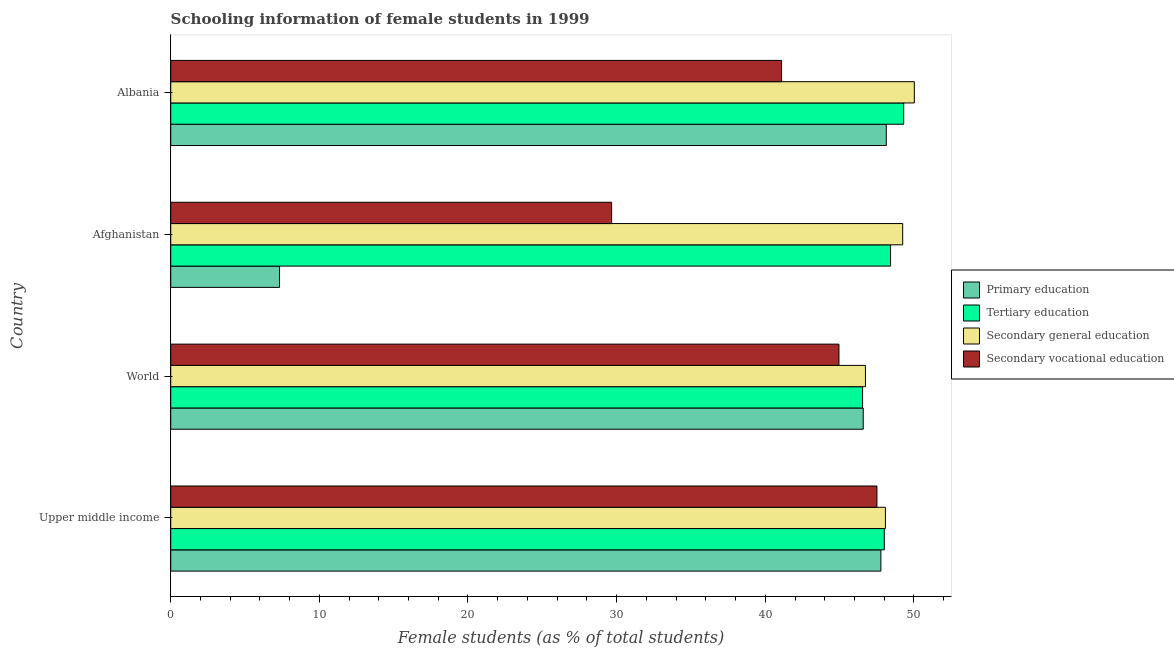How many different coloured bars are there?
Provide a short and direct response. 4. How many groups of bars are there?
Offer a very short reply. 4. How many bars are there on the 3rd tick from the top?
Ensure brevity in your answer.  4. How many bars are there on the 1st tick from the bottom?
Give a very brief answer. 4. What is the label of the 4th group of bars from the top?
Give a very brief answer. Upper middle income. What is the percentage of female students in primary education in Upper middle income?
Keep it short and to the point. 47.78. Across all countries, what is the maximum percentage of female students in secondary vocational education?
Make the answer very short. 47.51. Across all countries, what is the minimum percentage of female students in secondary vocational education?
Your answer should be very brief. 29.66. In which country was the percentage of female students in primary education maximum?
Provide a short and direct response. Albania. In which country was the percentage of female students in secondary vocational education minimum?
Offer a terse response. Afghanistan. What is the total percentage of female students in tertiary education in the graph?
Your answer should be compact. 192.3. What is the difference between the percentage of female students in tertiary education in Afghanistan and that in World?
Give a very brief answer. 1.88. What is the difference between the percentage of female students in primary education in World and the percentage of female students in secondary education in Upper middle income?
Your answer should be very brief. -1.49. What is the average percentage of female students in secondary vocational education per country?
Ensure brevity in your answer.  40.81. What is the difference between the percentage of female students in tertiary education and percentage of female students in secondary vocational education in World?
Keep it short and to the point. 1.59. In how many countries, is the percentage of female students in tertiary education greater than 44 %?
Keep it short and to the point. 4. What is the ratio of the percentage of female students in secondary vocational education in Upper middle income to that in World?
Make the answer very short. 1.06. Is the percentage of female students in tertiary education in Albania less than that in World?
Offer a very short reply. No. Is the difference between the percentage of female students in primary education in Afghanistan and Upper middle income greater than the difference between the percentage of female students in secondary education in Afghanistan and Upper middle income?
Keep it short and to the point. No. What is the difference between the highest and the second highest percentage of female students in primary education?
Provide a short and direct response. 0.36. What is the difference between the highest and the lowest percentage of female students in secondary vocational education?
Keep it short and to the point. 17.85. Is the sum of the percentage of female students in tertiary education in Albania and Upper middle income greater than the maximum percentage of female students in secondary education across all countries?
Your response must be concise. Yes. Is it the case that in every country, the sum of the percentage of female students in primary education and percentage of female students in tertiary education is greater than the sum of percentage of female students in secondary education and percentage of female students in secondary vocational education?
Your response must be concise. No. What does the 3rd bar from the top in World represents?
Provide a short and direct response. Tertiary education. What does the 2nd bar from the bottom in Upper middle income represents?
Ensure brevity in your answer.  Tertiary education. Are the values on the major ticks of X-axis written in scientific E-notation?
Offer a very short reply. No. Does the graph contain any zero values?
Make the answer very short. No. Where does the legend appear in the graph?
Offer a very short reply. Center right. How are the legend labels stacked?
Your answer should be compact. Vertical. What is the title of the graph?
Offer a terse response. Schooling information of female students in 1999. What is the label or title of the X-axis?
Provide a short and direct response. Female students (as % of total students). What is the Female students (as % of total students) of Primary education in Upper middle income?
Give a very brief answer. 47.78. What is the Female students (as % of total students) in Tertiary education in Upper middle income?
Give a very brief answer. 48.01. What is the Female students (as % of total students) in Secondary general education in Upper middle income?
Keep it short and to the point. 48.08. What is the Female students (as % of total students) of Secondary vocational education in Upper middle income?
Your answer should be very brief. 47.51. What is the Female students (as % of total students) of Primary education in World?
Your answer should be very brief. 46.59. What is the Female students (as % of total students) of Tertiary education in World?
Give a very brief answer. 46.55. What is the Female students (as % of total students) of Secondary general education in World?
Ensure brevity in your answer.  46.74. What is the Female students (as % of total students) of Secondary vocational education in World?
Your answer should be very brief. 44.96. What is the Female students (as % of total students) of Primary education in Afghanistan?
Your answer should be compact. 7.32. What is the Female students (as % of total students) of Tertiary education in Afghanistan?
Your answer should be compact. 48.43. What is the Female students (as % of total students) of Secondary general education in Afghanistan?
Keep it short and to the point. 49.25. What is the Female students (as % of total students) of Secondary vocational education in Afghanistan?
Give a very brief answer. 29.66. What is the Female students (as % of total students) in Primary education in Albania?
Ensure brevity in your answer.  48.14. What is the Female students (as % of total students) in Tertiary education in Albania?
Your answer should be compact. 49.31. What is the Female students (as % of total students) of Secondary general education in Albania?
Your answer should be compact. 50.03. What is the Female students (as % of total students) of Secondary vocational education in Albania?
Provide a succinct answer. 41.1. Across all countries, what is the maximum Female students (as % of total students) of Primary education?
Make the answer very short. 48.14. Across all countries, what is the maximum Female students (as % of total students) in Tertiary education?
Your answer should be very brief. 49.31. Across all countries, what is the maximum Female students (as % of total students) of Secondary general education?
Offer a terse response. 50.03. Across all countries, what is the maximum Female students (as % of total students) in Secondary vocational education?
Your answer should be compact. 47.51. Across all countries, what is the minimum Female students (as % of total students) in Primary education?
Provide a succinct answer. 7.32. Across all countries, what is the minimum Female students (as % of total students) in Tertiary education?
Offer a very short reply. 46.55. Across all countries, what is the minimum Female students (as % of total students) in Secondary general education?
Your answer should be compact. 46.74. Across all countries, what is the minimum Female students (as % of total students) in Secondary vocational education?
Provide a succinct answer. 29.66. What is the total Female students (as % of total students) of Primary education in the graph?
Your answer should be compact. 149.83. What is the total Female students (as % of total students) in Tertiary education in the graph?
Your answer should be very brief. 192.3. What is the total Female students (as % of total students) of Secondary general education in the graph?
Your answer should be compact. 194.1. What is the total Female students (as % of total students) in Secondary vocational education in the graph?
Offer a terse response. 163.23. What is the difference between the Female students (as % of total students) of Primary education in Upper middle income and that in World?
Give a very brief answer. 1.19. What is the difference between the Female students (as % of total students) of Tertiary education in Upper middle income and that in World?
Your response must be concise. 1.46. What is the difference between the Female students (as % of total students) in Secondary general education in Upper middle income and that in World?
Keep it short and to the point. 1.34. What is the difference between the Female students (as % of total students) in Secondary vocational education in Upper middle income and that in World?
Offer a very short reply. 2.55. What is the difference between the Female students (as % of total students) of Primary education in Upper middle income and that in Afghanistan?
Your response must be concise. 40.46. What is the difference between the Female students (as % of total students) in Tertiary education in Upper middle income and that in Afghanistan?
Give a very brief answer. -0.42. What is the difference between the Female students (as % of total students) of Secondary general education in Upper middle income and that in Afghanistan?
Provide a succinct answer. -1.16. What is the difference between the Female students (as % of total students) in Secondary vocational education in Upper middle income and that in Afghanistan?
Your answer should be very brief. 17.85. What is the difference between the Female students (as % of total students) of Primary education in Upper middle income and that in Albania?
Give a very brief answer. -0.36. What is the difference between the Female students (as % of total students) in Tertiary education in Upper middle income and that in Albania?
Keep it short and to the point. -1.3. What is the difference between the Female students (as % of total students) in Secondary general education in Upper middle income and that in Albania?
Provide a short and direct response. -1.94. What is the difference between the Female students (as % of total students) in Secondary vocational education in Upper middle income and that in Albania?
Provide a short and direct response. 6.42. What is the difference between the Female students (as % of total students) of Primary education in World and that in Afghanistan?
Your answer should be compact. 39.27. What is the difference between the Female students (as % of total students) of Tertiary education in World and that in Afghanistan?
Offer a very short reply. -1.88. What is the difference between the Female students (as % of total students) in Secondary general education in World and that in Afghanistan?
Ensure brevity in your answer.  -2.51. What is the difference between the Female students (as % of total students) of Secondary vocational education in World and that in Afghanistan?
Offer a terse response. 15.29. What is the difference between the Female students (as % of total students) of Primary education in World and that in Albania?
Provide a succinct answer. -1.55. What is the difference between the Female students (as % of total students) of Tertiary education in World and that in Albania?
Offer a very short reply. -2.77. What is the difference between the Female students (as % of total students) of Secondary general education in World and that in Albania?
Make the answer very short. -3.29. What is the difference between the Female students (as % of total students) of Secondary vocational education in World and that in Albania?
Ensure brevity in your answer.  3.86. What is the difference between the Female students (as % of total students) of Primary education in Afghanistan and that in Albania?
Make the answer very short. -40.82. What is the difference between the Female students (as % of total students) of Tertiary education in Afghanistan and that in Albania?
Your response must be concise. -0.88. What is the difference between the Female students (as % of total students) of Secondary general education in Afghanistan and that in Albania?
Give a very brief answer. -0.78. What is the difference between the Female students (as % of total students) of Secondary vocational education in Afghanistan and that in Albania?
Make the answer very short. -11.43. What is the difference between the Female students (as % of total students) in Primary education in Upper middle income and the Female students (as % of total students) in Tertiary education in World?
Keep it short and to the point. 1.23. What is the difference between the Female students (as % of total students) in Primary education in Upper middle income and the Female students (as % of total students) in Secondary general education in World?
Your answer should be very brief. 1.04. What is the difference between the Female students (as % of total students) of Primary education in Upper middle income and the Female students (as % of total students) of Secondary vocational education in World?
Your response must be concise. 2.82. What is the difference between the Female students (as % of total students) of Tertiary education in Upper middle income and the Female students (as % of total students) of Secondary general education in World?
Provide a succinct answer. 1.27. What is the difference between the Female students (as % of total students) in Tertiary education in Upper middle income and the Female students (as % of total students) in Secondary vocational education in World?
Your answer should be compact. 3.05. What is the difference between the Female students (as % of total students) of Secondary general education in Upper middle income and the Female students (as % of total students) of Secondary vocational education in World?
Ensure brevity in your answer.  3.13. What is the difference between the Female students (as % of total students) in Primary education in Upper middle income and the Female students (as % of total students) in Tertiary education in Afghanistan?
Make the answer very short. -0.65. What is the difference between the Female students (as % of total students) of Primary education in Upper middle income and the Female students (as % of total students) of Secondary general education in Afghanistan?
Make the answer very short. -1.47. What is the difference between the Female students (as % of total students) of Primary education in Upper middle income and the Female students (as % of total students) of Secondary vocational education in Afghanistan?
Keep it short and to the point. 18.11. What is the difference between the Female students (as % of total students) of Tertiary education in Upper middle income and the Female students (as % of total students) of Secondary general education in Afghanistan?
Give a very brief answer. -1.24. What is the difference between the Female students (as % of total students) in Tertiary education in Upper middle income and the Female students (as % of total students) in Secondary vocational education in Afghanistan?
Give a very brief answer. 18.35. What is the difference between the Female students (as % of total students) of Secondary general education in Upper middle income and the Female students (as % of total students) of Secondary vocational education in Afghanistan?
Provide a short and direct response. 18.42. What is the difference between the Female students (as % of total students) in Primary education in Upper middle income and the Female students (as % of total students) in Tertiary education in Albania?
Your answer should be compact. -1.54. What is the difference between the Female students (as % of total students) in Primary education in Upper middle income and the Female students (as % of total students) in Secondary general education in Albania?
Your answer should be very brief. -2.25. What is the difference between the Female students (as % of total students) in Primary education in Upper middle income and the Female students (as % of total students) in Secondary vocational education in Albania?
Ensure brevity in your answer.  6.68. What is the difference between the Female students (as % of total students) of Tertiary education in Upper middle income and the Female students (as % of total students) of Secondary general education in Albania?
Offer a very short reply. -2.02. What is the difference between the Female students (as % of total students) of Tertiary education in Upper middle income and the Female students (as % of total students) of Secondary vocational education in Albania?
Your answer should be very brief. 6.91. What is the difference between the Female students (as % of total students) of Secondary general education in Upper middle income and the Female students (as % of total students) of Secondary vocational education in Albania?
Offer a very short reply. 6.99. What is the difference between the Female students (as % of total students) in Primary education in World and the Female students (as % of total students) in Tertiary education in Afghanistan?
Your answer should be very brief. -1.84. What is the difference between the Female students (as % of total students) of Primary education in World and the Female students (as % of total students) of Secondary general education in Afghanistan?
Keep it short and to the point. -2.65. What is the difference between the Female students (as % of total students) of Primary education in World and the Female students (as % of total students) of Secondary vocational education in Afghanistan?
Offer a terse response. 16.93. What is the difference between the Female students (as % of total students) of Tertiary education in World and the Female students (as % of total students) of Secondary general education in Afghanistan?
Ensure brevity in your answer.  -2.7. What is the difference between the Female students (as % of total students) in Tertiary education in World and the Female students (as % of total students) in Secondary vocational education in Afghanistan?
Your answer should be very brief. 16.88. What is the difference between the Female students (as % of total students) of Secondary general education in World and the Female students (as % of total students) of Secondary vocational education in Afghanistan?
Your answer should be very brief. 17.08. What is the difference between the Female students (as % of total students) of Primary education in World and the Female students (as % of total students) of Tertiary education in Albania?
Your answer should be compact. -2.72. What is the difference between the Female students (as % of total students) in Primary education in World and the Female students (as % of total students) in Secondary general education in Albania?
Offer a very short reply. -3.44. What is the difference between the Female students (as % of total students) in Primary education in World and the Female students (as % of total students) in Secondary vocational education in Albania?
Your response must be concise. 5.5. What is the difference between the Female students (as % of total students) of Tertiary education in World and the Female students (as % of total students) of Secondary general education in Albania?
Your answer should be very brief. -3.48. What is the difference between the Female students (as % of total students) in Tertiary education in World and the Female students (as % of total students) in Secondary vocational education in Albania?
Make the answer very short. 5.45. What is the difference between the Female students (as % of total students) of Secondary general education in World and the Female students (as % of total students) of Secondary vocational education in Albania?
Your response must be concise. 5.64. What is the difference between the Female students (as % of total students) in Primary education in Afghanistan and the Female students (as % of total students) in Tertiary education in Albania?
Ensure brevity in your answer.  -41.99. What is the difference between the Female students (as % of total students) of Primary education in Afghanistan and the Female students (as % of total students) of Secondary general education in Albania?
Your answer should be very brief. -42.71. What is the difference between the Female students (as % of total students) in Primary education in Afghanistan and the Female students (as % of total students) in Secondary vocational education in Albania?
Keep it short and to the point. -33.77. What is the difference between the Female students (as % of total students) in Tertiary education in Afghanistan and the Female students (as % of total students) in Secondary general education in Albania?
Your answer should be compact. -1.6. What is the difference between the Female students (as % of total students) in Tertiary education in Afghanistan and the Female students (as % of total students) in Secondary vocational education in Albania?
Offer a terse response. 7.34. What is the difference between the Female students (as % of total students) of Secondary general education in Afghanistan and the Female students (as % of total students) of Secondary vocational education in Albania?
Your response must be concise. 8.15. What is the average Female students (as % of total students) of Primary education per country?
Offer a very short reply. 37.46. What is the average Female students (as % of total students) of Tertiary education per country?
Offer a terse response. 48.07. What is the average Female students (as % of total students) of Secondary general education per country?
Your response must be concise. 48.52. What is the average Female students (as % of total students) of Secondary vocational education per country?
Offer a very short reply. 40.81. What is the difference between the Female students (as % of total students) of Primary education and Female students (as % of total students) of Tertiary education in Upper middle income?
Make the answer very short. -0.23. What is the difference between the Female students (as % of total students) in Primary education and Female students (as % of total students) in Secondary general education in Upper middle income?
Ensure brevity in your answer.  -0.31. What is the difference between the Female students (as % of total students) in Primary education and Female students (as % of total students) in Secondary vocational education in Upper middle income?
Your answer should be compact. 0.27. What is the difference between the Female students (as % of total students) in Tertiary education and Female students (as % of total students) in Secondary general education in Upper middle income?
Offer a terse response. -0.07. What is the difference between the Female students (as % of total students) of Tertiary education and Female students (as % of total students) of Secondary vocational education in Upper middle income?
Offer a terse response. 0.5. What is the difference between the Female students (as % of total students) of Secondary general education and Female students (as % of total students) of Secondary vocational education in Upper middle income?
Provide a succinct answer. 0.57. What is the difference between the Female students (as % of total students) in Primary education and Female students (as % of total students) in Tertiary education in World?
Provide a short and direct response. 0.04. What is the difference between the Female students (as % of total students) of Primary education and Female students (as % of total students) of Secondary general education in World?
Provide a short and direct response. -0.15. What is the difference between the Female students (as % of total students) of Primary education and Female students (as % of total students) of Secondary vocational education in World?
Your answer should be very brief. 1.63. What is the difference between the Female students (as % of total students) in Tertiary education and Female students (as % of total students) in Secondary general education in World?
Your response must be concise. -0.19. What is the difference between the Female students (as % of total students) of Tertiary education and Female students (as % of total students) of Secondary vocational education in World?
Make the answer very short. 1.59. What is the difference between the Female students (as % of total students) of Secondary general education and Female students (as % of total students) of Secondary vocational education in World?
Provide a succinct answer. 1.78. What is the difference between the Female students (as % of total students) of Primary education and Female students (as % of total students) of Tertiary education in Afghanistan?
Your answer should be compact. -41.11. What is the difference between the Female students (as % of total students) of Primary education and Female students (as % of total students) of Secondary general education in Afghanistan?
Keep it short and to the point. -41.92. What is the difference between the Female students (as % of total students) of Primary education and Female students (as % of total students) of Secondary vocational education in Afghanistan?
Offer a terse response. -22.34. What is the difference between the Female students (as % of total students) in Tertiary education and Female students (as % of total students) in Secondary general education in Afghanistan?
Offer a very short reply. -0.82. What is the difference between the Female students (as % of total students) in Tertiary education and Female students (as % of total students) in Secondary vocational education in Afghanistan?
Offer a terse response. 18.77. What is the difference between the Female students (as % of total students) in Secondary general education and Female students (as % of total students) in Secondary vocational education in Afghanistan?
Your response must be concise. 19.58. What is the difference between the Female students (as % of total students) of Primary education and Female students (as % of total students) of Tertiary education in Albania?
Ensure brevity in your answer.  -1.17. What is the difference between the Female students (as % of total students) of Primary education and Female students (as % of total students) of Secondary general education in Albania?
Your answer should be compact. -1.89. What is the difference between the Female students (as % of total students) of Primary education and Female students (as % of total students) of Secondary vocational education in Albania?
Ensure brevity in your answer.  7.05. What is the difference between the Female students (as % of total students) in Tertiary education and Female students (as % of total students) in Secondary general education in Albania?
Offer a very short reply. -0.72. What is the difference between the Female students (as % of total students) in Tertiary education and Female students (as % of total students) in Secondary vocational education in Albania?
Give a very brief answer. 8.22. What is the difference between the Female students (as % of total students) of Secondary general education and Female students (as % of total students) of Secondary vocational education in Albania?
Keep it short and to the point. 8.93. What is the ratio of the Female students (as % of total students) of Primary education in Upper middle income to that in World?
Ensure brevity in your answer.  1.03. What is the ratio of the Female students (as % of total students) in Tertiary education in Upper middle income to that in World?
Offer a terse response. 1.03. What is the ratio of the Female students (as % of total students) of Secondary general education in Upper middle income to that in World?
Provide a short and direct response. 1.03. What is the ratio of the Female students (as % of total students) in Secondary vocational education in Upper middle income to that in World?
Your answer should be compact. 1.06. What is the ratio of the Female students (as % of total students) in Primary education in Upper middle income to that in Afghanistan?
Make the answer very short. 6.53. What is the ratio of the Female students (as % of total students) of Tertiary education in Upper middle income to that in Afghanistan?
Give a very brief answer. 0.99. What is the ratio of the Female students (as % of total students) in Secondary general education in Upper middle income to that in Afghanistan?
Your answer should be very brief. 0.98. What is the ratio of the Female students (as % of total students) in Secondary vocational education in Upper middle income to that in Afghanistan?
Ensure brevity in your answer.  1.6. What is the ratio of the Female students (as % of total students) of Tertiary education in Upper middle income to that in Albania?
Provide a succinct answer. 0.97. What is the ratio of the Female students (as % of total students) in Secondary general education in Upper middle income to that in Albania?
Offer a terse response. 0.96. What is the ratio of the Female students (as % of total students) in Secondary vocational education in Upper middle income to that in Albania?
Your answer should be compact. 1.16. What is the ratio of the Female students (as % of total students) of Primary education in World to that in Afghanistan?
Give a very brief answer. 6.36. What is the ratio of the Female students (as % of total students) in Tertiary education in World to that in Afghanistan?
Your answer should be compact. 0.96. What is the ratio of the Female students (as % of total students) in Secondary general education in World to that in Afghanistan?
Provide a short and direct response. 0.95. What is the ratio of the Female students (as % of total students) in Secondary vocational education in World to that in Afghanistan?
Your response must be concise. 1.52. What is the ratio of the Female students (as % of total students) of Primary education in World to that in Albania?
Offer a terse response. 0.97. What is the ratio of the Female students (as % of total students) of Tertiary education in World to that in Albania?
Ensure brevity in your answer.  0.94. What is the ratio of the Female students (as % of total students) in Secondary general education in World to that in Albania?
Your answer should be very brief. 0.93. What is the ratio of the Female students (as % of total students) in Secondary vocational education in World to that in Albania?
Offer a very short reply. 1.09. What is the ratio of the Female students (as % of total students) of Primary education in Afghanistan to that in Albania?
Give a very brief answer. 0.15. What is the ratio of the Female students (as % of total students) of Tertiary education in Afghanistan to that in Albania?
Provide a succinct answer. 0.98. What is the ratio of the Female students (as % of total students) of Secondary general education in Afghanistan to that in Albania?
Offer a very short reply. 0.98. What is the ratio of the Female students (as % of total students) of Secondary vocational education in Afghanistan to that in Albania?
Keep it short and to the point. 0.72. What is the difference between the highest and the second highest Female students (as % of total students) of Primary education?
Your answer should be compact. 0.36. What is the difference between the highest and the second highest Female students (as % of total students) of Tertiary education?
Keep it short and to the point. 0.88. What is the difference between the highest and the second highest Female students (as % of total students) of Secondary general education?
Make the answer very short. 0.78. What is the difference between the highest and the second highest Female students (as % of total students) of Secondary vocational education?
Your response must be concise. 2.55. What is the difference between the highest and the lowest Female students (as % of total students) of Primary education?
Give a very brief answer. 40.82. What is the difference between the highest and the lowest Female students (as % of total students) in Tertiary education?
Your response must be concise. 2.77. What is the difference between the highest and the lowest Female students (as % of total students) of Secondary general education?
Your answer should be very brief. 3.29. What is the difference between the highest and the lowest Female students (as % of total students) of Secondary vocational education?
Provide a short and direct response. 17.85. 